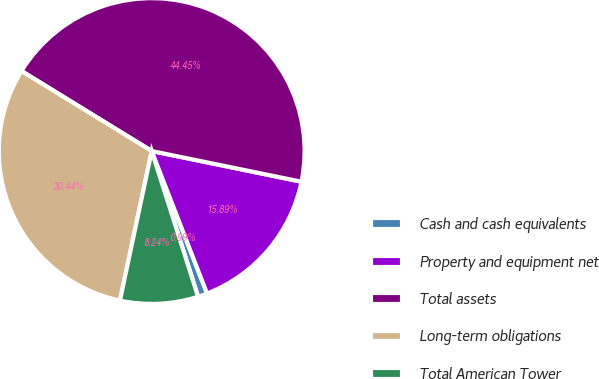<chart> <loc_0><loc_0><loc_500><loc_500><pie_chart><fcel>Cash and cash equivalents<fcel>Property and equipment net<fcel>Total assets<fcel>Long-term obligations<fcel>Total American Tower<nl><fcel>0.99%<fcel>15.89%<fcel>44.45%<fcel>30.44%<fcel>8.24%<nl></chart> 